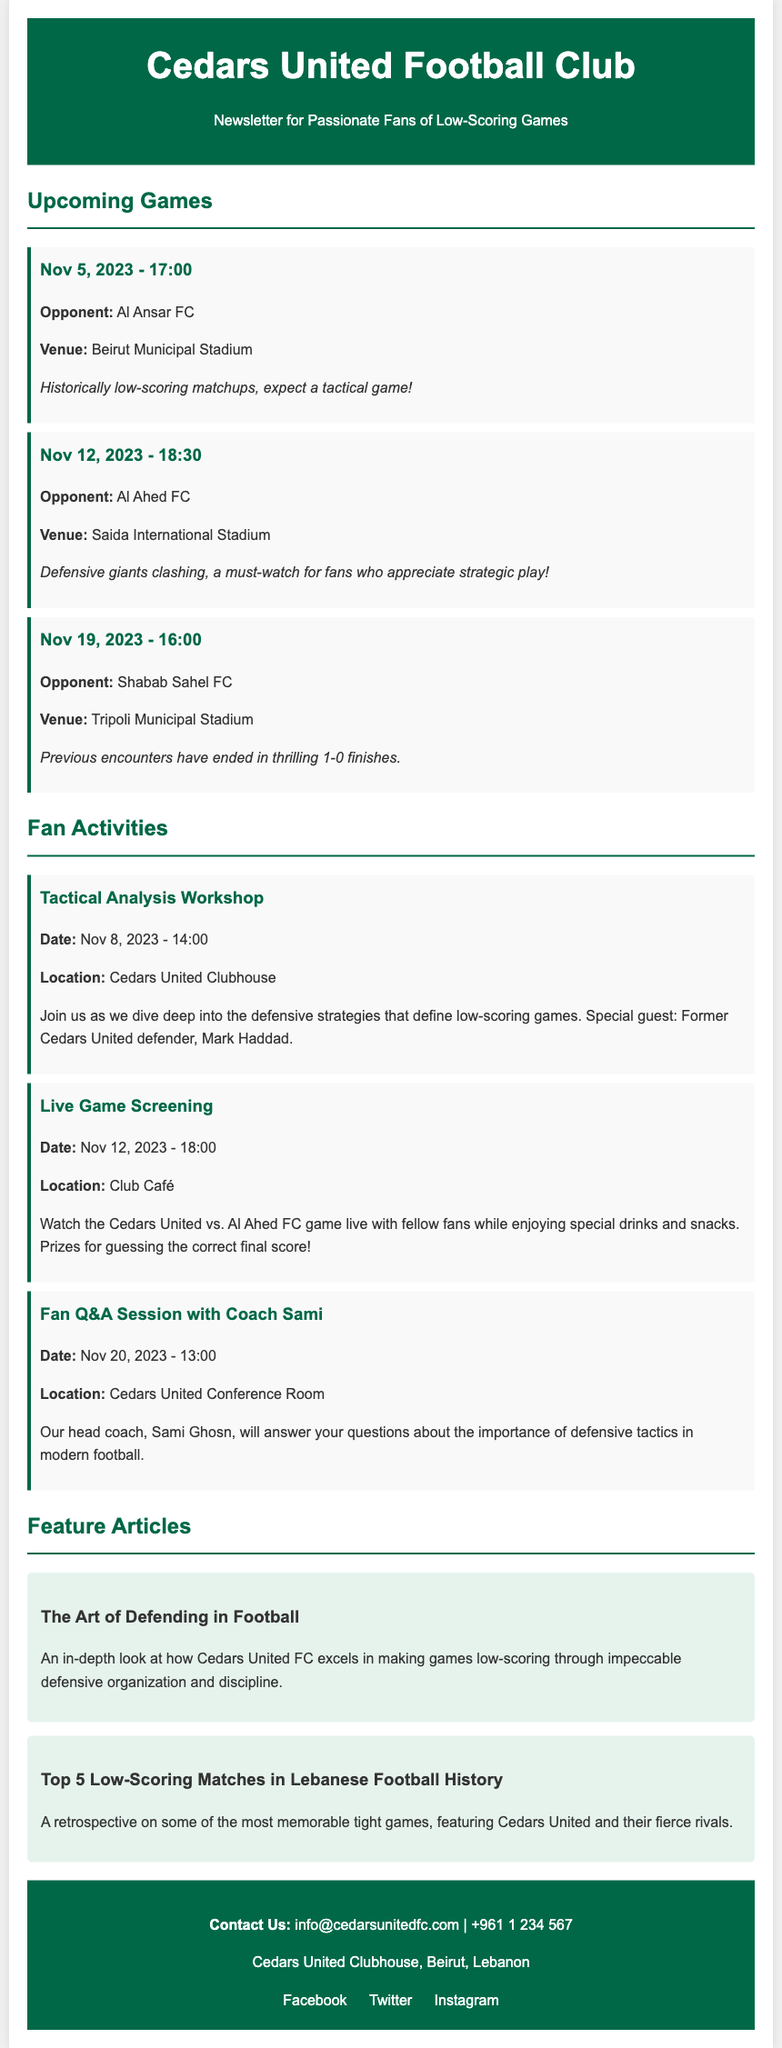What is the next game for Cedars United FC? The next upcoming game for Cedars United FC is listed in the document, which includes the date and opponent.
Answer: Nov 5, 2023 - Al Ansar FC Where will the game against Al Ahed FC take place? The venue for the game against Al Ahed FC is mentioned in the document.
Answer: Saida International Stadium What time is the tactical analysis workshop scheduled? The document provides the specific time for the tactical analysis workshop.
Answer: 14:00 Who is the special guest at the Tactical Analysis Workshop? The document identifies the special guest for the workshop.
Answer: Mark Haddad How many upcoming games are listed in the document? The document specifies the number of upcoming games under the section "Upcoming Games."
Answer: 3 What type of session will be held on Nov 20, 2023? The document describes the nature of the session scheduled on that date.
Answer: Fan Q&A Session What is the main focus of the feature article titled "The Art of Defending in Football"? The title of the feature article provides insight into its primary focus, which is discussed in detail in the document.
Answer: Defensive organization When is the live game screening event? The document states the date for the live game screening event.
Answer: Nov 12, 2023 - 18:00 